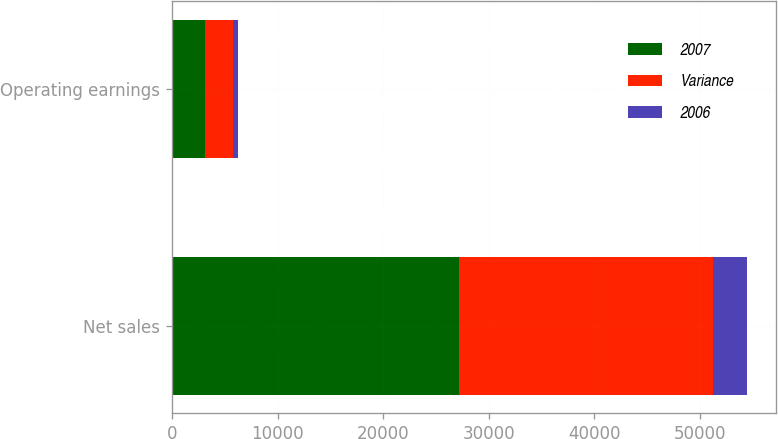<chart> <loc_0><loc_0><loc_500><loc_500><stacked_bar_chart><ecel><fcel>Net sales<fcel>Operating earnings<nl><fcel>2007<fcel>27240<fcel>3113<nl><fcel>Variance<fcel>24063<fcel>2625<nl><fcel>2006<fcel>3177<fcel>488<nl></chart> 